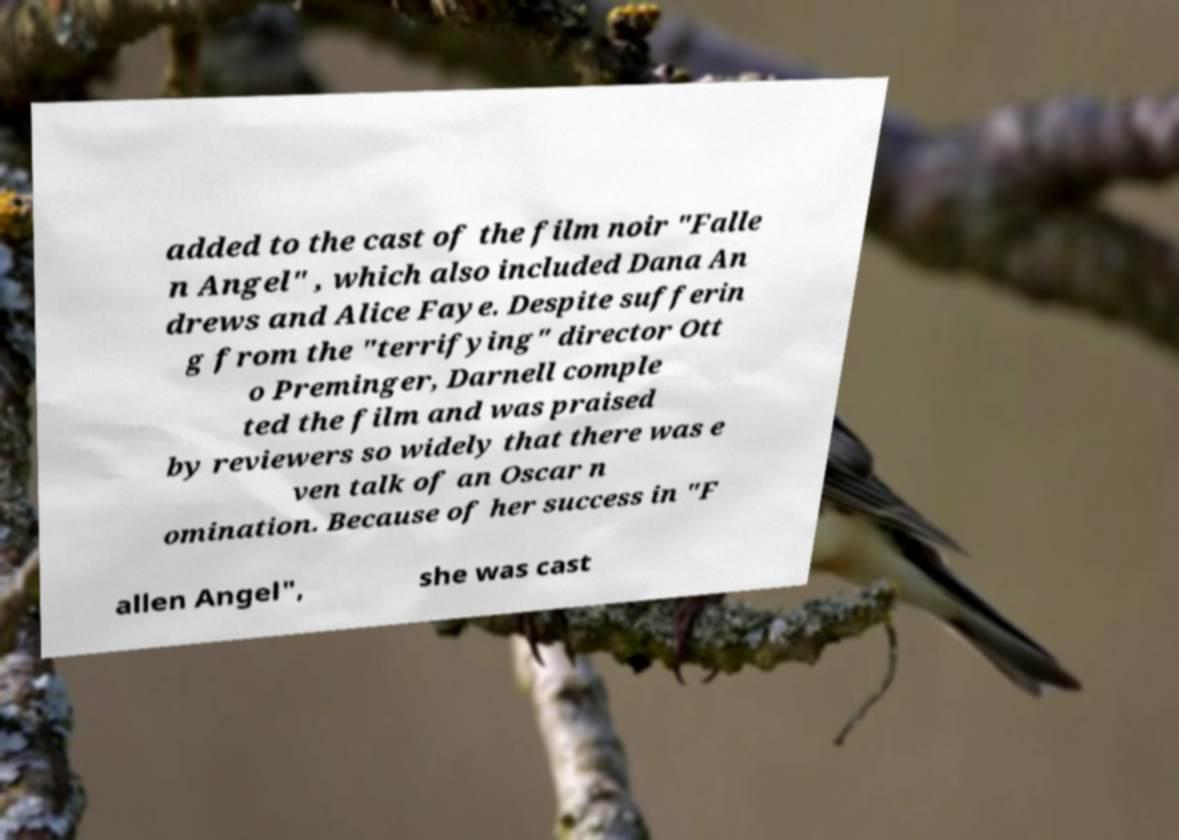Could you extract and type out the text from this image? added to the cast of the film noir "Falle n Angel" , which also included Dana An drews and Alice Faye. Despite sufferin g from the "terrifying" director Ott o Preminger, Darnell comple ted the film and was praised by reviewers so widely that there was e ven talk of an Oscar n omination. Because of her success in "F allen Angel", she was cast 